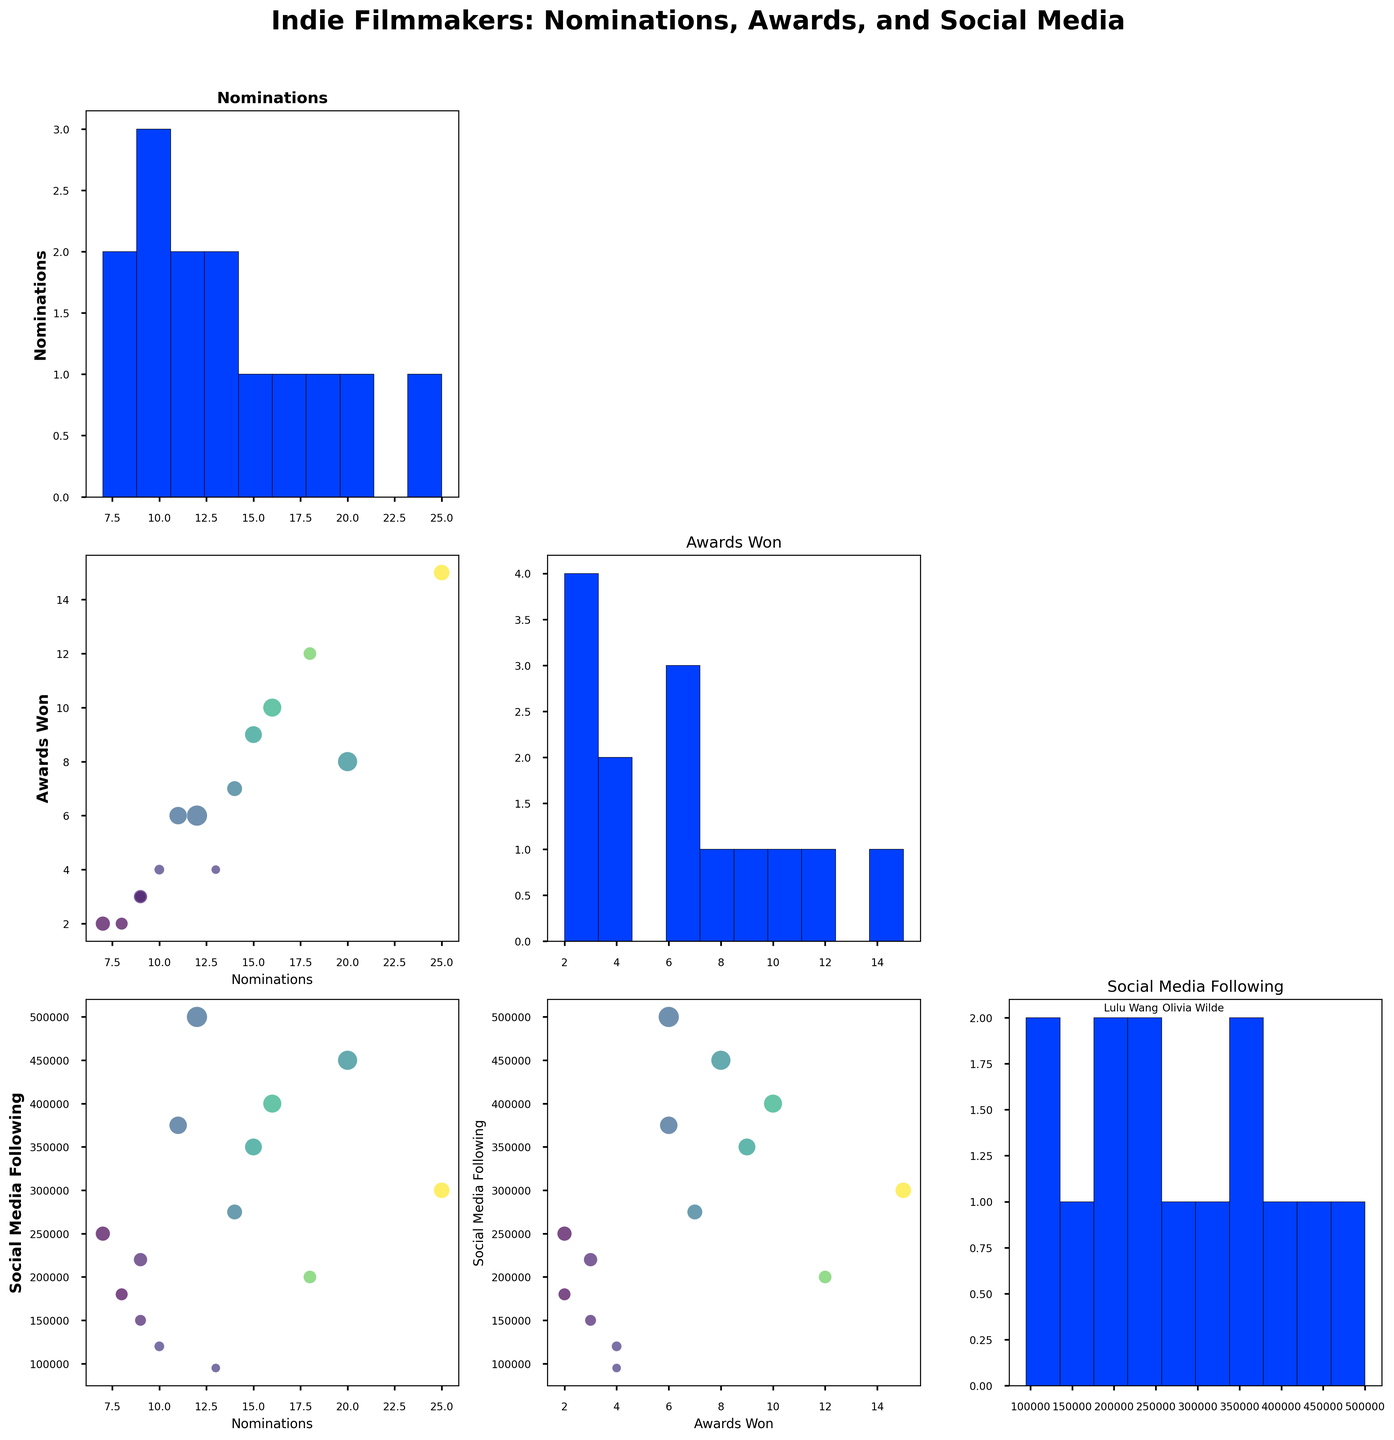What's the title of the figure? The title is typically written at the top of the figure. In this case, it is "Indie Filmmakers: Nominations, Awards, and Social Media".
Answer: Indie Filmmakers: Nominations, Awards, and Social Media Which filmmaker has the highest number of awards won? The scatter plot shows the awards won on the y-axis. The filmmaker with the highest point on this axis is the one with the most awards.
Answer: Bong Joon-ho What is the relationship between social media following and awards won for Chloé Zhao? Locate Chloé Zhao's point on the scatter plot with social media following on the x-axis and awards won on the y-axis. Chloé Zhao has a high number of awards and a substantial social media following.
Answer: Positive relationship How many filmmakers have more than 300,000 social media followers? Identify the points on the x-axis (social media following) above the 300,000 mark and count them.
Answer: Four Compare the awards won by Jordan Peele and Lee Isaac Chung. Who has won more awards? Find both filmmakers on the scatter plot and compare the points on the y-axis corresponding to awards won.
Answer: Jordan Peele What is the range of nominations received by the filmmakers? The range is calculated by subtracting the lowest number of nominations from the highest number, which can be seen in the nominations histogram. The smallest value is 7 and the largest is 25.
Answer: 18 Which two variables seem to have the most direct positive correlation? Examine the scatter plots in the SPLOM and determine which pair has points most closely aligned in an upward trend.
Answer: Nominations and Awards Won Is there any filmmaker with both low social media following and high awards won? Look for points that are low on the x-axis (social media following) but high on the y-axis (awards won).
Answer: No Who has exactly 15 nominations? Find the point in the scatter plots where the nomination histogram shows a peak at 15. Use the labels to identify the filmmaker.
Answer: Greta Gerwig What’s the average number of awards won by filmmakers with more than 200,000 social media followers? Identify filmmakers with more than 200,000 social media followers and calculate the average number of awards for these filmmakers. For more than 200,000 followers: Barry Jenkins (12), Alfonso Cuarón (8), Bong Joon-ho (15), Olivia Wilde (2), Jordan Peele (6), Chloé Zhao (10), Ryan Coogler (6) → Sum = 59, Count = 7 → Average = 59/7.
Answer: 8.43 